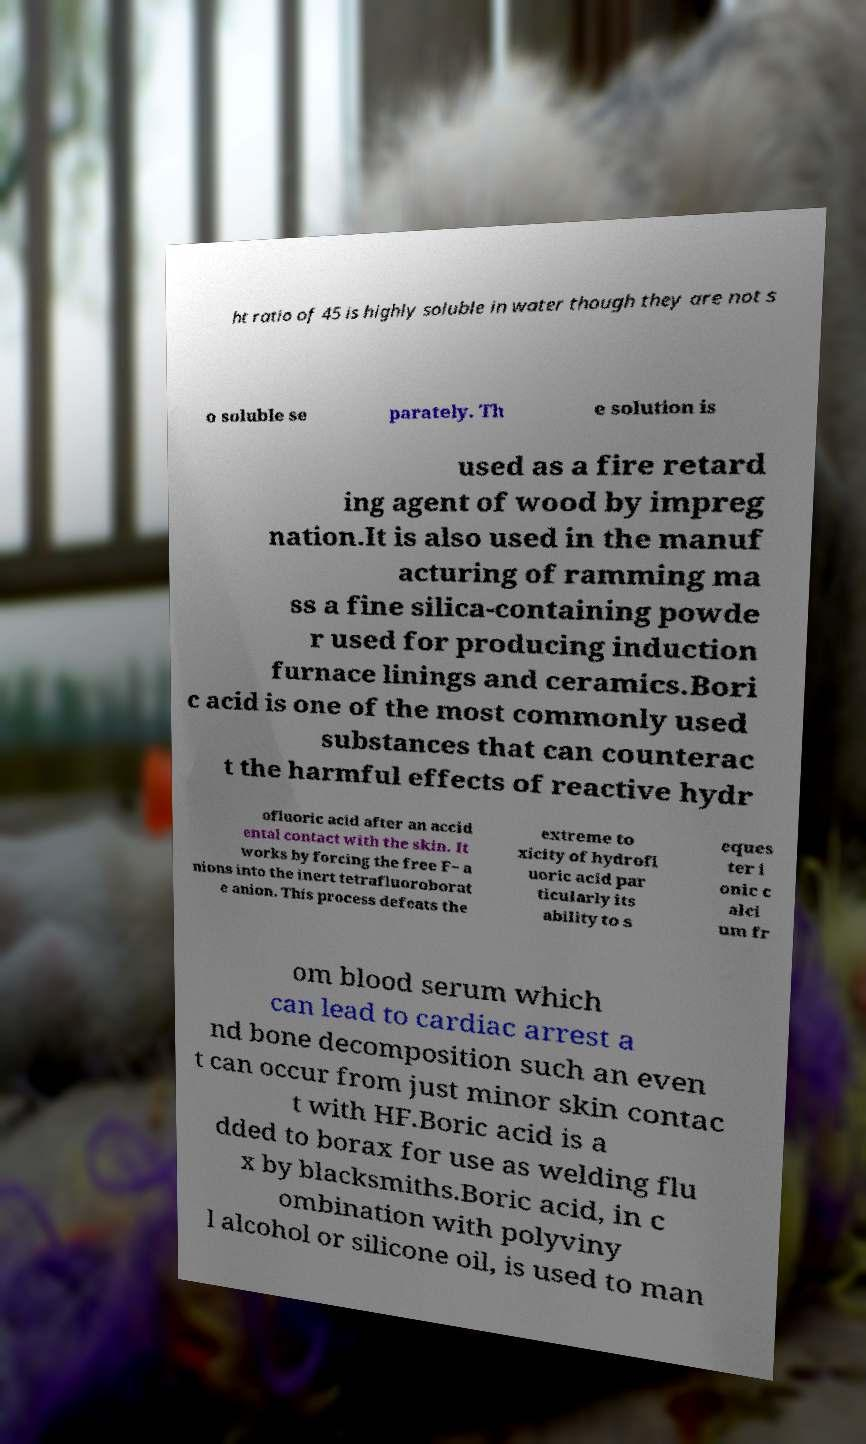Could you assist in decoding the text presented in this image and type it out clearly? ht ratio of 45 is highly soluble in water though they are not s o soluble se parately. Th e solution is used as a fire retard ing agent of wood by impreg nation.It is also used in the manuf acturing of ramming ma ss a fine silica-containing powde r used for producing induction furnace linings and ceramics.Bori c acid is one of the most commonly used substances that can counterac t the harmful effects of reactive hydr ofluoric acid after an accid ental contact with the skin. It works by forcing the free F− a nions into the inert tetrafluoroborat e anion. This process defeats the extreme to xicity of hydrofl uoric acid par ticularly its ability to s eques ter i onic c alci um fr om blood serum which can lead to cardiac arrest a nd bone decomposition such an even t can occur from just minor skin contac t with HF.Boric acid is a dded to borax for use as welding flu x by blacksmiths.Boric acid, in c ombination with polyviny l alcohol or silicone oil, is used to man 